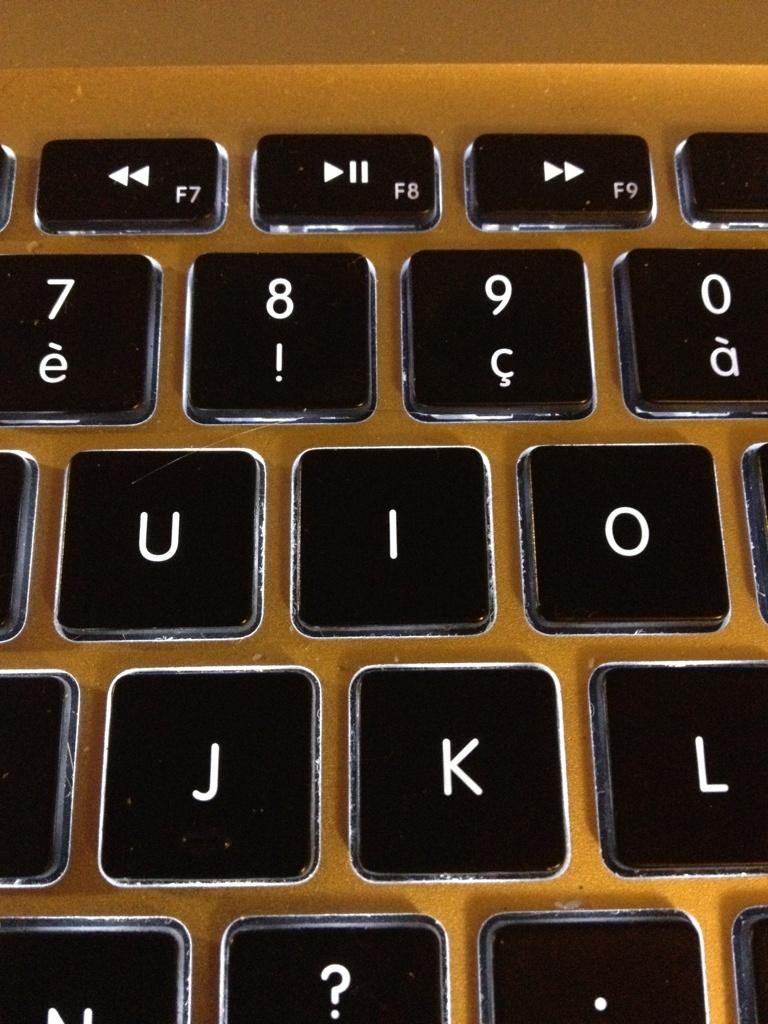<image>
Relay a brief, clear account of the picture shown. a close up of a key board with keys K and J shown 